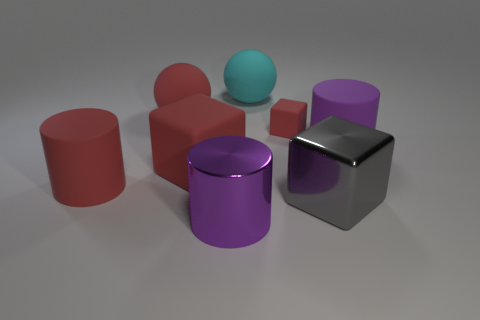Is the number of cyan matte balls that are in front of the big red ball greater than the number of small brown matte balls?
Your response must be concise. No. Is there a large metal cube that has the same color as the small rubber object?
Ensure brevity in your answer.  No. What color is the metal block that is the same size as the cyan object?
Give a very brief answer. Gray. There is a purple thing left of the large gray block; is there a red thing that is in front of it?
Your answer should be very brief. No. What is the ball that is right of the metal cylinder made of?
Your answer should be very brief. Rubber. Do the big red object that is behind the large purple matte object and the large purple thing behind the large red cylinder have the same material?
Make the answer very short. Yes. Are there the same number of small objects that are to the left of the cyan matte ball and balls on the left side of the red cylinder?
Provide a succinct answer. Yes. How many brown balls are the same material as the small red thing?
Offer a very short reply. 0. What is the shape of the large rubber object that is the same color as the metal cylinder?
Keep it short and to the point. Cylinder. There is a block that is in front of the big matte cylinder on the left side of the tiny rubber thing; what is its size?
Offer a very short reply. Large. 